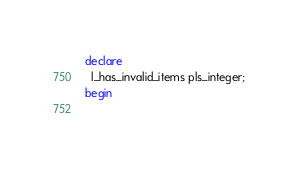<code> <loc_0><loc_0><loc_500><loc_500><_SQL_>declare
  l_has_invalid_items pls_integer;
begin
  </code> 